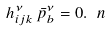Convert formula to latex. <formula><loc_0><loc_0><loc_500><loc_500>h ^ { \nu } _ { i j k } \, \bar { p } ^ { \nu } _ { b } = 0 . \ n</formula> 